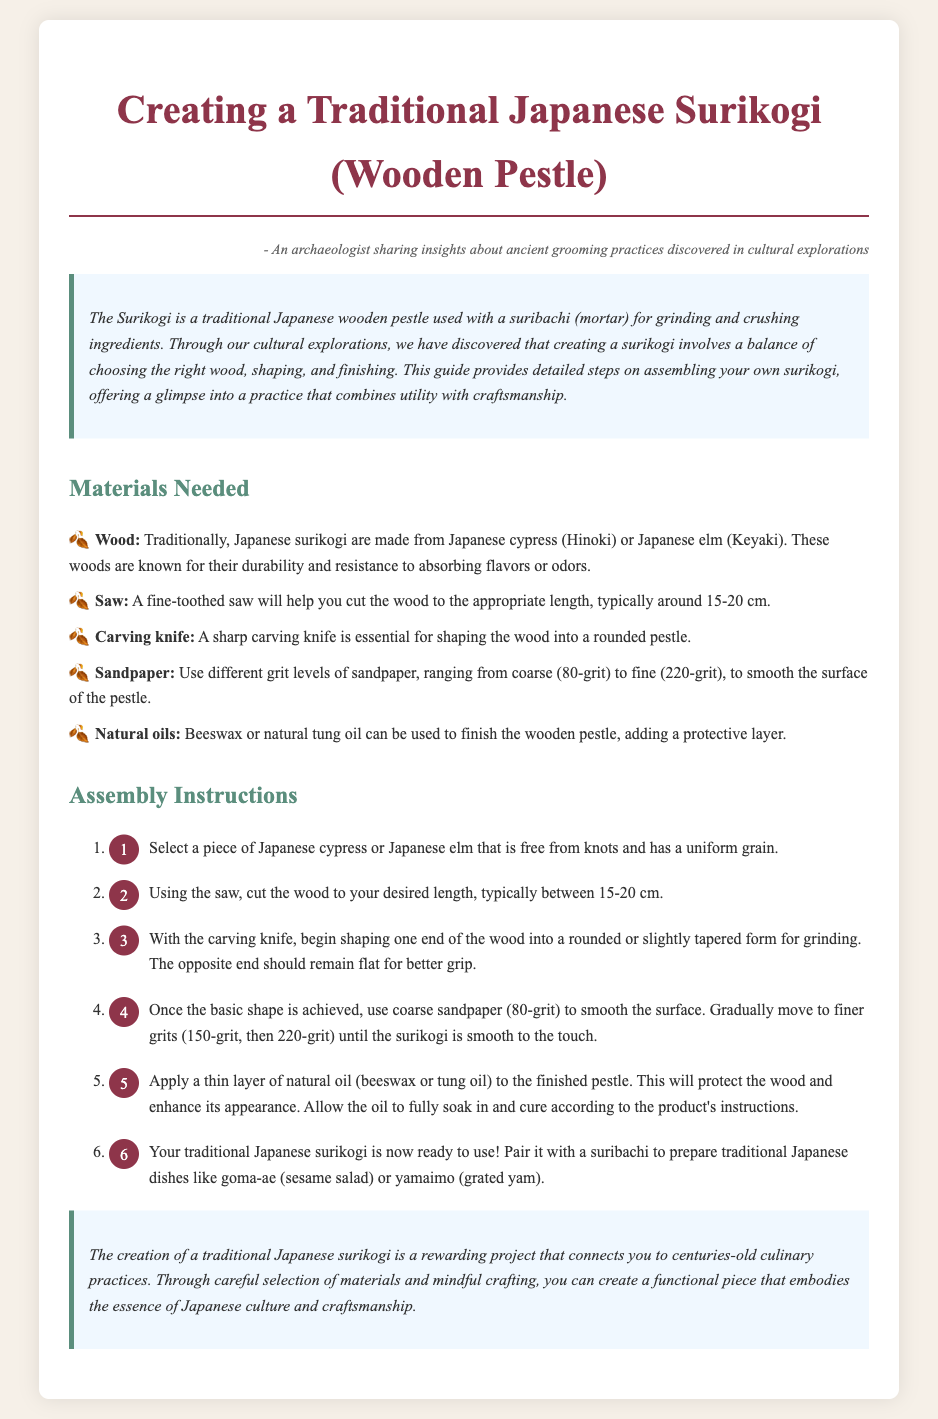What is a surikogi? A surikogi is a traditional Japanese wooden pestle used with a suribachi for grinding and crushing ingredients.
Answer: Wooden pestle What type of wood is traditionally used for a surikogi? The document specifies that traditional surikogi are made from Japanese cypress or Japanese elm.
Answer: Hinoki or Keyaki What is the typical length of a surikogi? The document states that the appropriate length of the wood is typically around 15-20 cm.
Answer: 15-20 cm What is the first step in creating a surikogi? The first step involves selecting a piece of Japanese cypress or Japanese elm that is free from knots.
Answer: Select a piece of wood What grit of sandpaper is used first to smooth the surface? The instructions indicate that coarse sandpaper (80-grit) is used first to smooth the surface.
Answer: 80-grit Why should natural oils be applied to the finished pestle? Natural oils are used to protect the wood and enhance its appearance, as stated in the assembly instructions.
Answer: Protect the wood What should the opposite end of the surikogi be like? The opposite end should remain flat for better grip according to the shaping instructions.
Answer: Flat for grip How many main materials are listed for making a surikogi? The document lists five main materials required for making a surikogi.
Answer: Five materials 